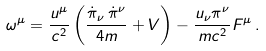<formula> <loc_0><loc_0><loc_500><loc_500>\omega ^ { \mu } = \frac { u ^ { \mu } } { c ^ { 2 } } \left ( \frac { \dot { \pi } _ { \nu } \, \dot { \pi } ^ { \nu } } { 4 m } + V \right ) - \frac { u _ { \nu } \pi ^ { \nu } } { m c ^ { 2 } } F ^ { \mu } \, .</formula> 